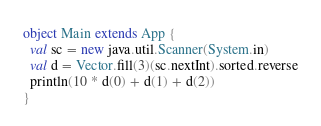Convert code to text. <code><loc_0><loc_0><loc_500><loc_500><_Scala_>object Main extends App {
  val sc = new java.util.Scanner(System.in)
  val d = Vector.fill(3)(sc.nextInt).sorted.reverse
  println(10 * d(0) + d(1) + d(2))
}</code> 